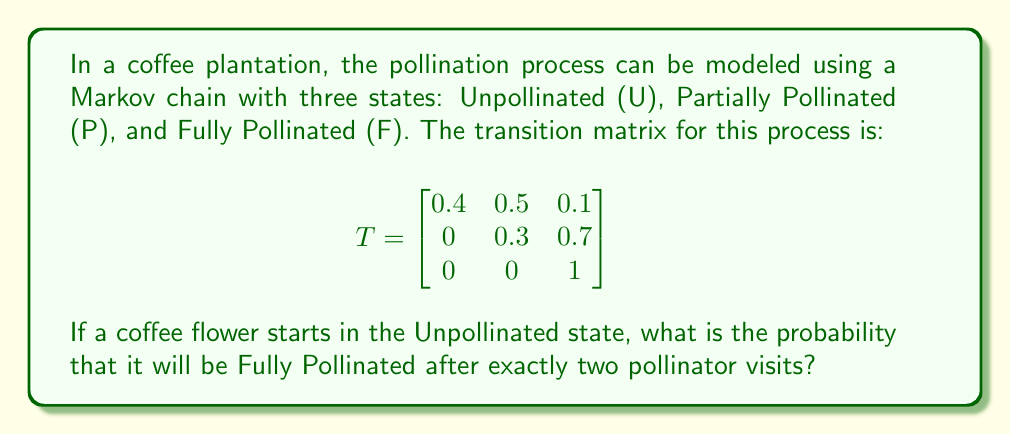Provide a solution to this math problem. To solve this problem, we need to use the properties of Markov chains and matrix multiplication. Let's approach this step-by-step:

1) The given transition matrix $T$ represents the probabilities of moving between states in a single step (or visit).

2) To find the probabilities after two steps, we need to multiply the transition matrix by itself:

   $$T^2 = T \times T = \begin{bmatrix}
   0.4 & 0.5 & 0.1 \\
   0 & 0.3 & 0.7 \\
   0 & 0 & 1
   \end{bmatrix} \times \begin{bmatrix}
   0.4 & 0.5 & 0.1 \\
   0 & 0.3 & 0.7 \\
   0 & 0 & 1
   \end{bmatrix}$$

3) Performing the matrix multiplication:

   $$T^2 = \begin{bmatrix}
   0.16 & 0.35 & 0.49 \\
   0 & 0.09 & 0.91 \\
   0 & 0 & 1
   \end{bmatrix}$$

4) The flower starts in the Unpollinated state, which corresponds to the first row of the resulting matrix.

5) The probability of being in the Fully Pollinated state (F) after two visits is given by the element in the first row, third column of $T^2$.

Therefore, the probability that a coffee flower starting in the Unpollinated state will be Fully Pollinated after exactly two pollinator visits is 0.49 or 49%.
Answer: 0.49 